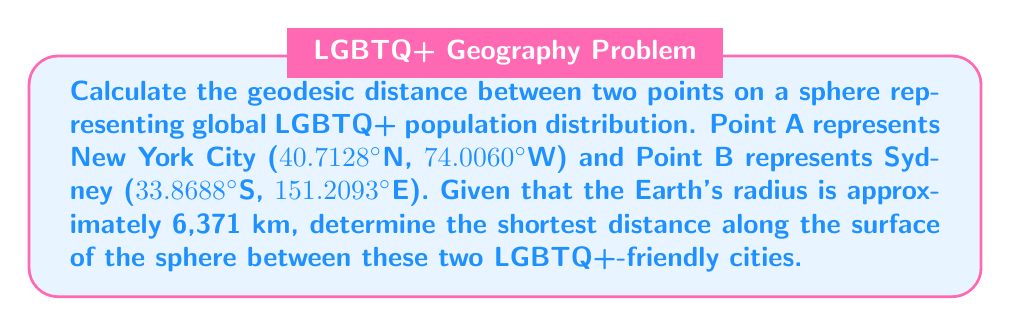Provide a solution to this math problem. To calculate the geodesic distance between two points on a sphere, we can use the Haversine formula. This formula is particularly useful for calculating great-circle distances on a sphere.

Step 1: Convert the latitude and longitude coordinates to radians.
$$\begin{align*}
\phi_1 &= 40.7128° \times \frac{\pi}{180} = 0.7102 \text{ rad} \\
\lambda_1 &= -74.0060° \times \frac{\pi}{180} = -1.2915 \text{ rad} \\
\phi_2 &= -33.8688° \times \frac{\pi}{180} = -0.5912 \text{ rad} \\
\lambda_2 &= 151.2093° \times \frac{\pi}{180} = 2.6386 \text{ rad}
\end{align*}$$

Step 2: Calculate the central angle $\Delta\sigma$ using the Haversine formula:
$$\begin{align*}
\Delta\sigma &= 2 \arcsin\left(\sqrt{\sin^2\left(\frac{\phi_2-\phi_1}{2}\right) + \cos(\phi_1)\cos(\phi_2)\sin^2\left(\frac{\lambda_2-\lambda_1}{2}\right)}\right) \\
&= 2 \arcsin\left(\sqrt{\sin^2\left(\frac{-0.5912-0.7102}{2}\right) + \cos(0.7102)\cos(-0.5912)\sin^2\left(\frac{2.6386-(-1.2915)}{2}\right)}\right) \\
&= 2 \arcsin\left(\sqrt{\sin^2(-0.6507) + \cos(0.7102)\cos(-0.5912)\sin^2(1.9651)}\right) \\
&= 2 \arcsin(\sqrt{0.3645 + 0.7500 \times 0.8416 \times 0.6369}) \\
&= 2 \arcsin(\sqrt{0.3645 + 0.4017}) \\
&= 2 \arcsin(\sqrt{0.7662}) \\
&= 2 \arcsin(0.8753) \\
&= 2 \times 1.0611 \\
&= 2.1222 \text{ rad}
\end{align*}$$

Step 3: Calculate the geodesic distance by multiplying the central angle by the Earth's radius:
$$\begin{align*}
d &= R \times \Delta\sigma \\
&= 6371 \text{ km} \times 2.1222 \text{ rad} \\
&= 13520.34 \text{ km}
\end{align*}$$

[asy]
import geometry;

size(200);
pair O=(0,0);
real R=5;
draw(circle(O,R));

pair A = R*dir(70);
pair B = R*dir(-150);

draw(O--A,dashed);
draw(O--B,dashed);
draw(Arc(O,A,B),red+1);

label("A (New York)",A,N);
label("B (Sydney)",B,SW);
label("O",O,SE);

[/asy]
Answer: The geodesic distance between New York City and Sydney on the surface of the Earth is approximately 13,520 km. 